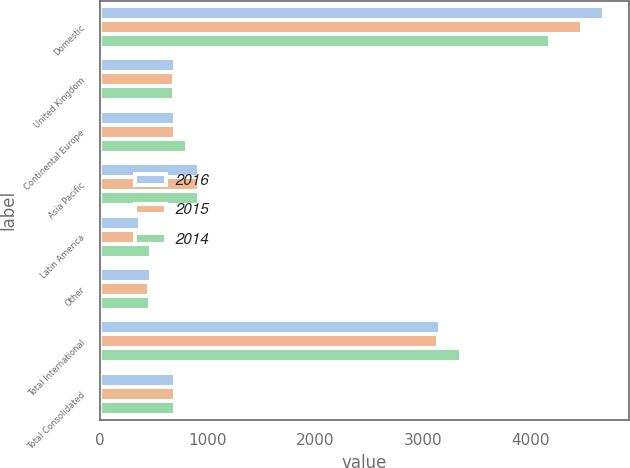<chart> <loc_0><loc_0><loc_500><loc_500><stacked_bar_chart><ecel><fcel>Domestic<fcel>United Kingdom<fcel>Continental Europe<fcel>Asia Pacific<fcel>Latin America<fcel>Other<fcel>Total International<fcel>Total Consolidated<nl><fcel>2016<fcel>4684.8<fcel>695.7<fcel>699.8<fcel>923<fcel>372.7<fcel>470.6<fcel>3161.8<fcel>699.8<nl><fcel>2015<fcel>4475.5<fcel>687.7<fcel>697.2<fcel>916.9<fcel>383.5<fcel>453<fcel>3138.3<fcel>699.8<nl><fcel>2014<fcel>4184<fcel>688.3<fcel>804.7<fcel>922.5<fcel>470.4<fcel>467.2<fcel>3353.1<fcel>699.8<nl></chart> 